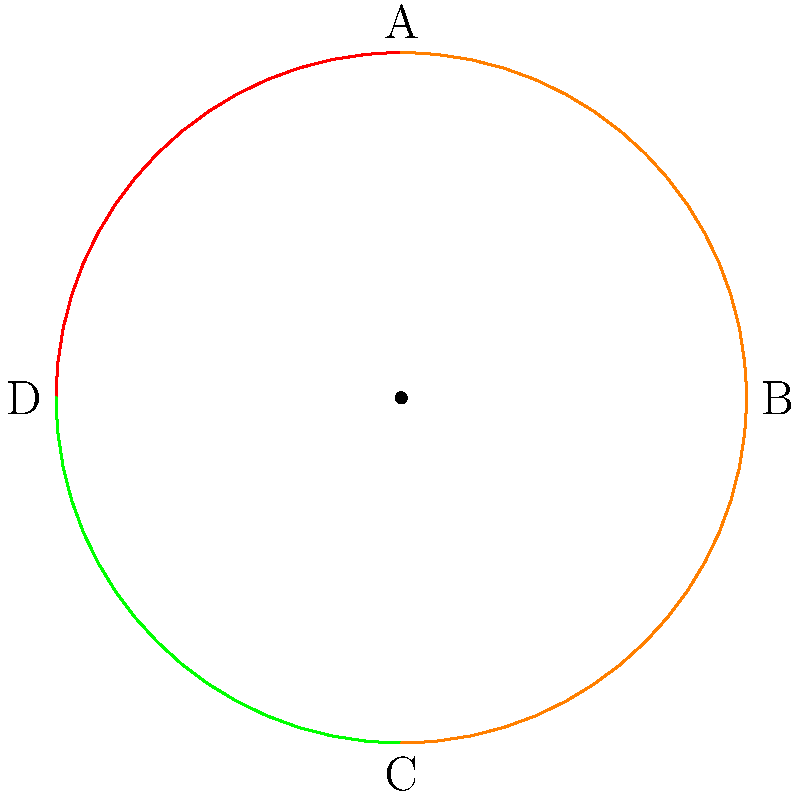The diagram shows a foldable radar dish design in its fully deployed state. If the dish is folded by rotating each quarter-circle segment 90 degrees inward towards the center, which segment will be on top in the fully folded configuration? To determine which segment will be on top in the fully folded configuration, we need to mentally visualize the folding process:

1. The dish is currently in a fully deployed state, forming a complete circle.
2. Each quarter-circle segment (A, B, C, D) will rotate 90 degrees inward towards the center.
3. Segment A (blue) is already in the topmost position. When folded, it will remain on top.
4. Segment B (red) will fold to the left, ending up under segment A.
5. Segment C (green) will fold upwards, ending up between segments A and B.
6. Segment D (orange) will fold to the right, ending up at the bottom of the stack.

The final stacking order from top to bottom will be: A, C, B, D.

Therefore, segment A will be on top in the fully folded configuration.
Answer: A 